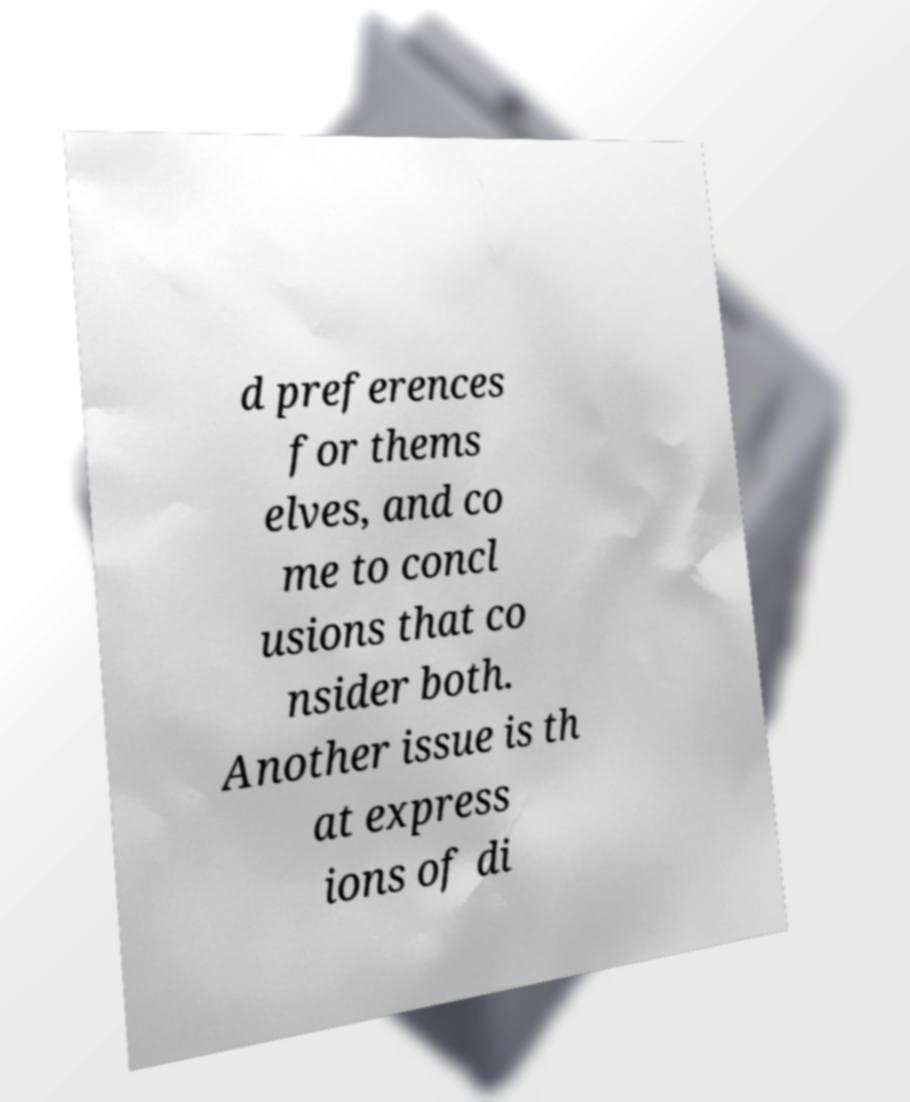I need the written content from this picture converted into text. Can you do that? d preferences for thems elves, and co me to concl usions that co nsider both. Another issue is th at express ions of di 